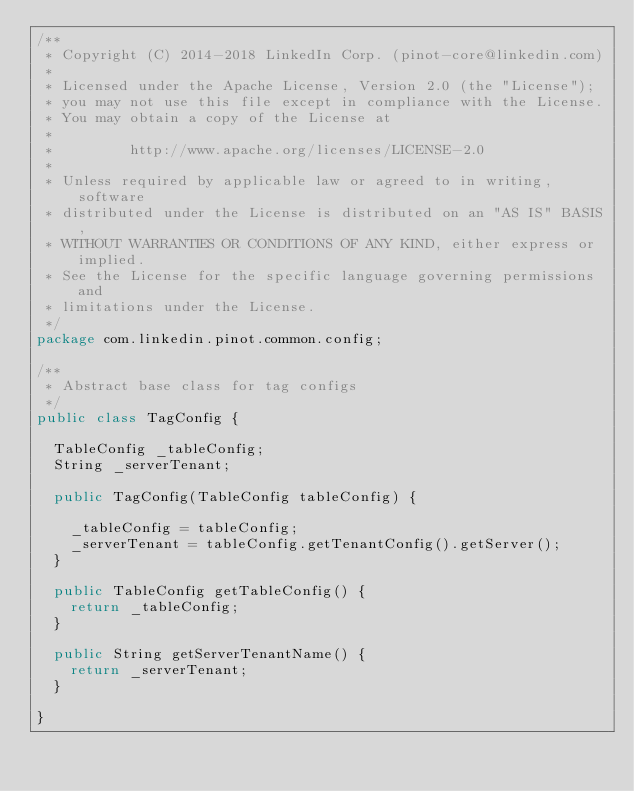<code> <loc_0><loc_0><loc_500><loc_500><_Java_>/**
 * Copyright (C) 2014-2018 LinkedIn Corp. (pinot-core@linkedin.com)
 *
 * Licensed under the Apache License, Version 2.0 (the "License");
 * you may not use this file except in compliance with the License.
 * You may obtain a copy of the License at
 *
 *         http://www.apache.org/licenses/LICENSE-2.0
 *
 * Unless required by applicable law or agreed to in writing, software
 * distributed under the License is distributed on an "AS IS" BASIS,
 * WITHOUT WARRANTIES OR CONDITIONS OF ANY KIND, either express or implied.
 * See the License for the specific language governing permissions and
 * limitations under the License.
 */
package com.linkedin.pinot.common.config;

/**
 * Abstract base class for tag configs
 */
public class TagConfig {

  TableConfig _tableConfig;
  String _serverTenant;

  public TagConfig(TableConfig tableConfig) {

    _tableConfig = tableConfig;
    _serverTenant = tableConfig.getTenantConfig().getServer();
  }

  public TableConfig getTableConfig() {
    return _tableConfig;
  }

  public String getServerTenantName() {
    return _serverTenant;
  }

}

</code> 